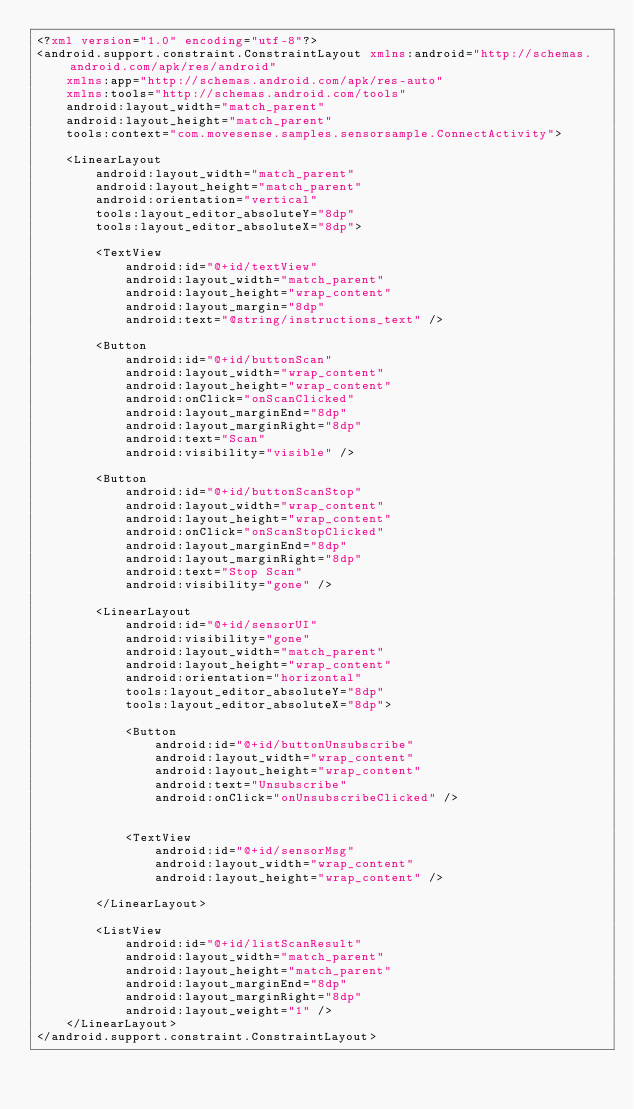Convert code to text. <code><loc_0><loc_0><loc_500><loc_500><_XML_><?xml version="1.0" encoding="utf-8"?>
<android.support.constraint.ConstraintLayout xmlns:android="http://schemas.android.com/apk/res/android"
    xmlns:app="http://schemas.android.com/apk/res-auto"
    xmlns:tools="http://schemas.android.com/tools"
    android:layout_width="match_parent"
    android:layout_height="match_parent"
    tools:context="com.movesense.samples.sensorsample.ConnectActivity">

    <LinearLayout
        android:layout_width="match_parent"
        android:layout_height="match_parent"
        android:orientation="vertical"
        tools:layout_editor_absoluteY="8dp"
        tools:layout_editor_absoluteX="8dp">

        <TextView
            android:id="@+id/textView"
            android:layout_width="match_parent"
            android:layout_height="wrap_content"
            android:layout_margin="8dp"
            android:text="@string/instructions_text" />

        <Button
            android:id="@+id/buttonScan"
            android:layout_width="wrap_content"
            android:layout_height="wrap_content"
            android:onClick="onScanClicked"
            android:layout_marginEnd="8dp"
            android:layout_marginRight="8dp"
            android:text="Scan"
            android:visibility="visible" />

        <Button
            android:id="@+id/buttonScanStop"
            android:layout_width="wrap_content"
            android:layout_height="wrap_content"
            android:onClick="onScanStopClicked"
            android:layout_marginEnd="8dp"
            android:layout_marginRight="8dp"
            android:text="Stop Scan"
            android:visibility="gone" />

        <LinearLayout
            android:id="@+id/sensorUI"
            android:visibility="gone"
            android:layout_width="match_parent"
            android:layout_height="wrap_content"
            android:orientation="horizontal"
            tools:layout_editor_absoluteY="8dp"
            tools:layout_editor_absoluteX="8dp">

            <Button
                android:id="@+id/buttonUnsubscribe"
                android:layout_width="wrap_content"
                android:layout_height="wrap_content"
                android:text="Unsubscribe"
                android:onClick="onUnsubscribeClicked" />


            <TextView
                android:id="@+id/sensorMsg"
                android:layout_width="wrap_content"
                android:layout_height="wrap_content" />

        </LinearLayout>

        <ListView
            android:id="@+id/listScanResult"
            android:layout_width="match_parent"
            android:layout_height="match_parent"
            android:layout_marginEnd="8dp"
            android:layout_marginRight="8dp"
            android:layout_weight="1" />
    </LinearLayout>
</android.support.constraint.ConstraintLayout>
</code> 